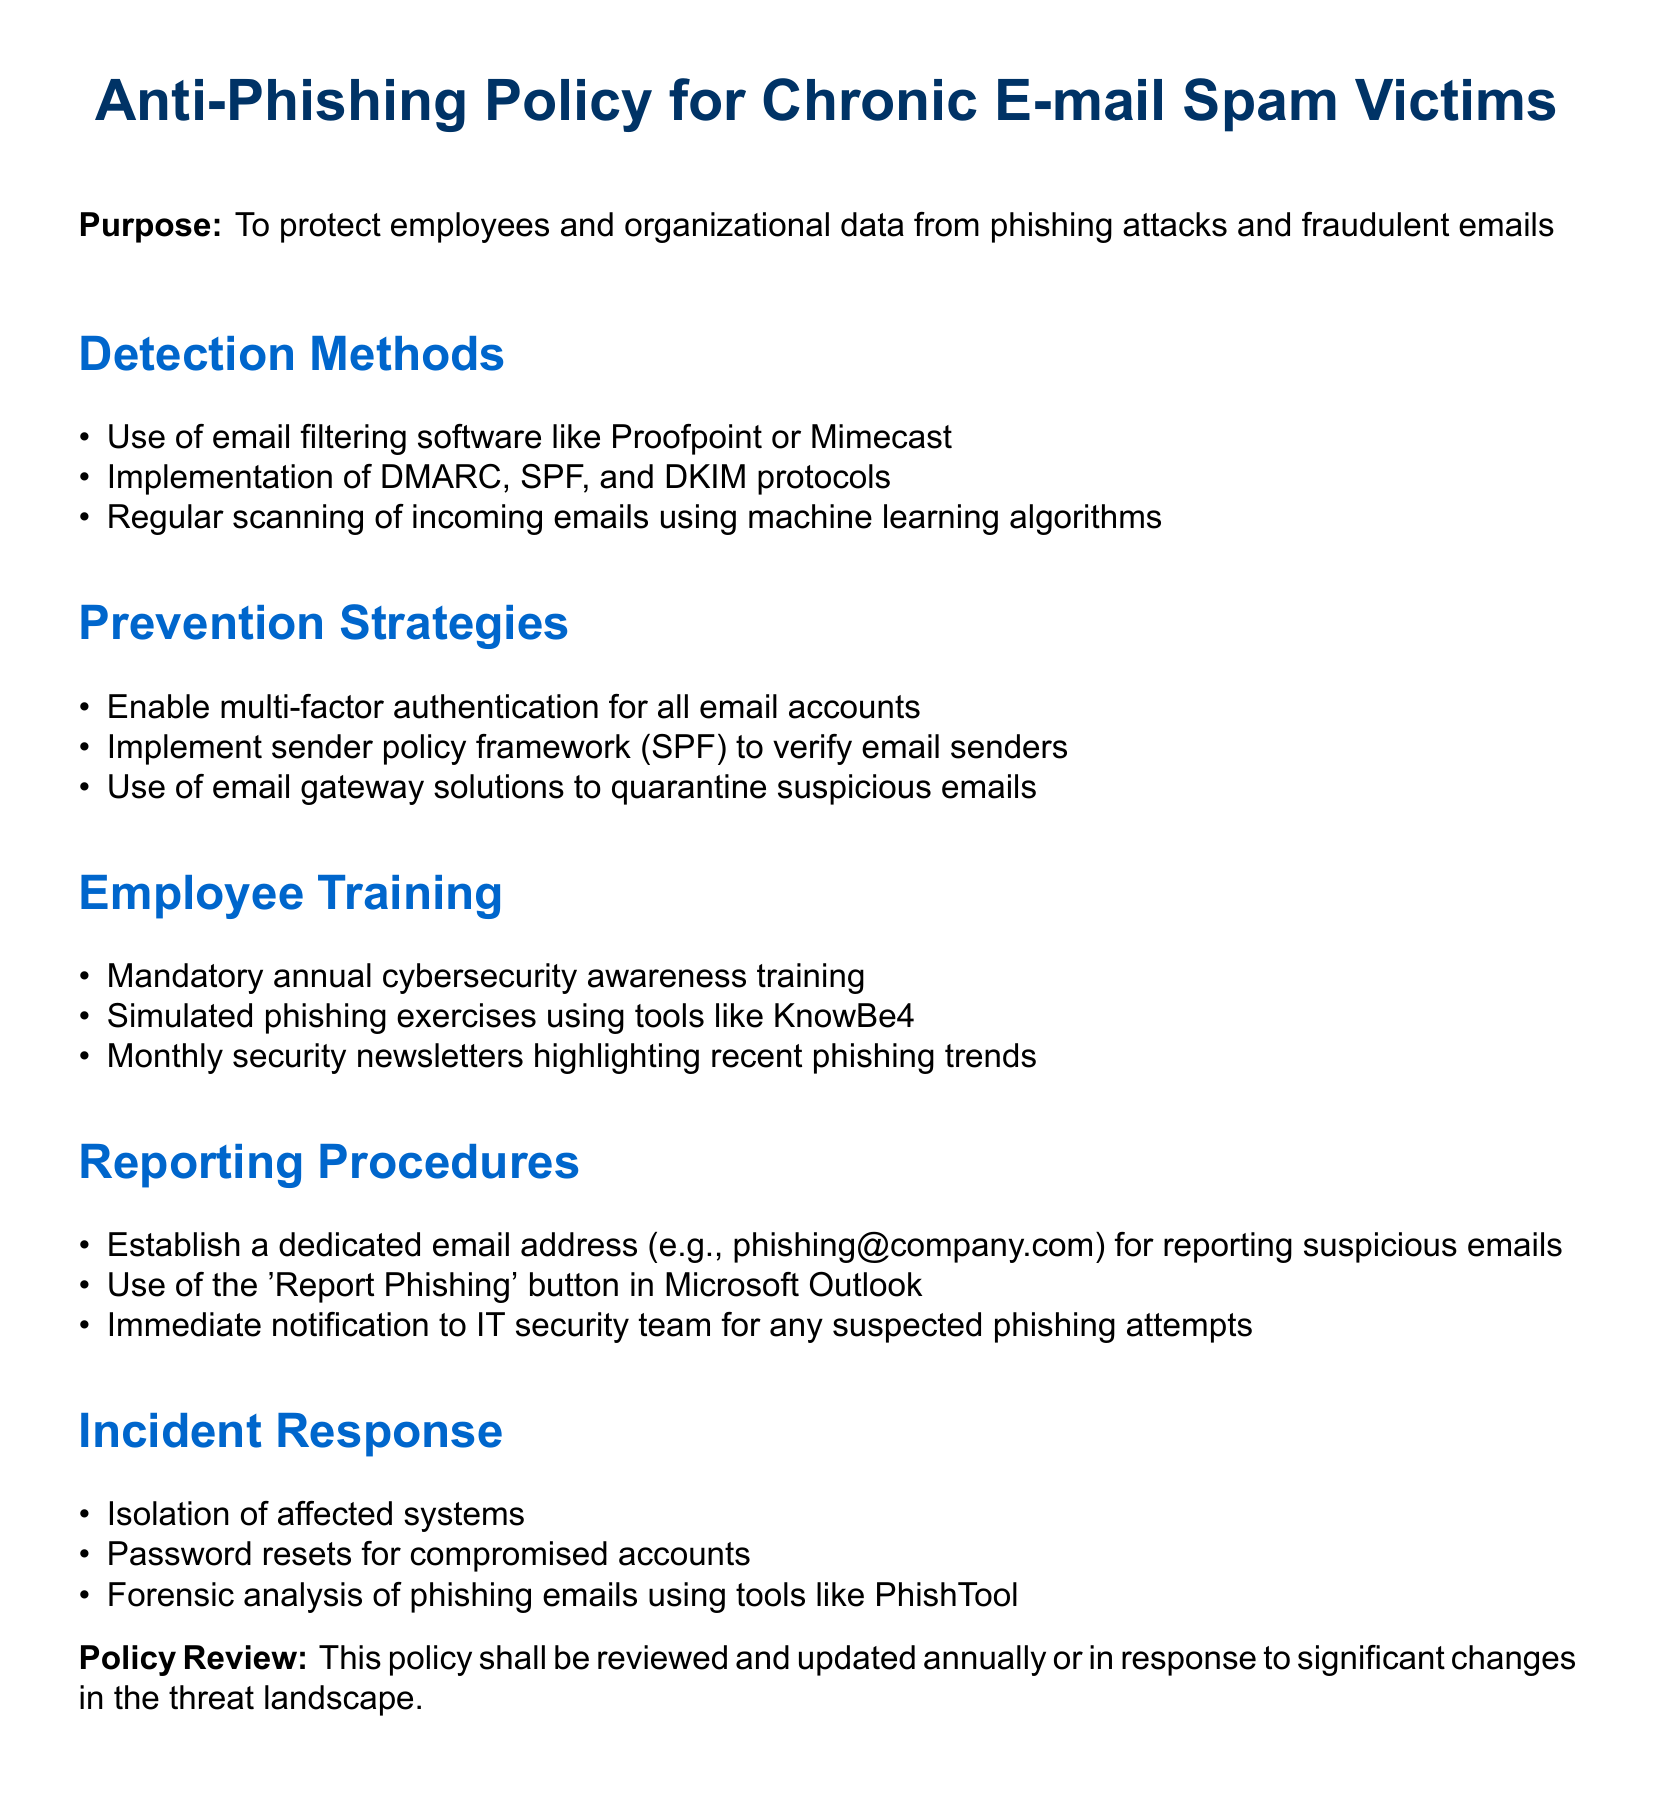what is the purpose of the document? The purpose is stated clearly at the beginning of the document, which is to protect employees and organizational data from phishing attacks and fraudulent emails.
Answer: To protect employees and organizational data from phishing attacks and fraudulent emails how often should the policy be reviewed? The document states that the policy shall be reviewed and updated annually or in response to significant changes in the threat landscape.
Answer: Annually what training is mandatory for employees? The document specifies that there is mandatory annual cybersecurity awareness training for employees.
Answer: Annual cybersecurity awareness training what protocol is used to verify email senders? The document mentions implementing the sender policy framework (SPF) to verify email senders.
Answer: Sender policy framework (SPF) how are suspicious emails reported? The document outlines that a dedicated email address is established for reporting suspicious emails, such as phishing@company.com.
Answer: phishing@company.com what method is used for incident response? Isolation of affected systems is listed as a key step in the incident response section of the document.
Answer: Isolation of affected systems what software is suggested for scanning emails? The document advises the use of email filtering software like Proofpoint or Mimecast for scanning emails.
Answer: Proofpoint or Mimecast which tool is used for simulated phishing exercises? The document specifies that tools like KnowBe4 are used for simulated phishing exercises.
Answer: KnowBe4 what should be done for compromised accounts? The document states that password resets should be performed for compromised accounts as part of incident response.
Answer: Password resets 